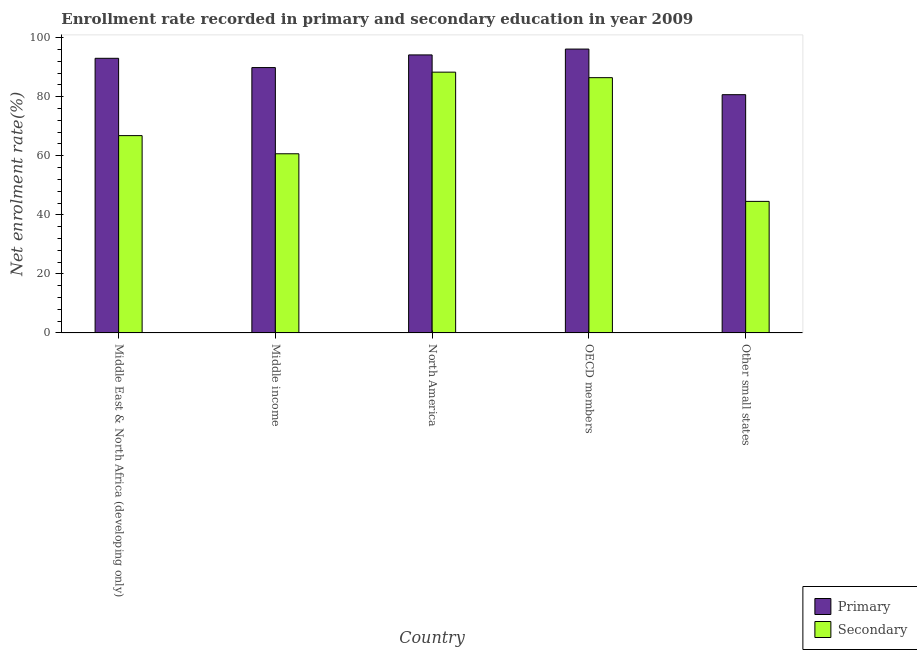How many different coloured bars are there?
Give a very brief answer. 2. How many groups of bars are there?
Your answer should be very brief. 5. Are the number of bars per tick equal to the number of legend labels?
Offer a very short reply. Yes. How many bars are there on the 3rd tick from the left?
Make the answer very short. 2. What is the label of the 5th group of bars from the left?
Your answer should be very brief. Other small states. What is the enrollment rate in secondary education in Middle income?
Ensure brevity in your answer.  60.68. Across all countries, what is the maximum enrollment rate in secondary education?
Offer a terse response. 88.32. Across all countries, what is the minimum enrollment rate in secondary education?
Your answer should be compact. 44.55. In which country was the enrollment rate in primary education minimum?
Your answer should be compact. Other small states. What is the total enrollment rate in secondary education in the graph?
Provide a short and direct response. 346.83. What is the difference between the enrollment rate in secondary education in Middle East & North Africa (developing only) and that in OECD members?
Offer a very short reply. -19.63. What is the difference between the enrollment rate in primary education in Middle East & North Africa (developing only) and the enrollment rate in secondary education in Other small states?
Ensure brevity in your answer.  48.45. What is the average enrollment rate in primary education per country?
Give a very brief answer. 90.77. What is the difference between the enrollment rate in primary education and enrollment rate in secondary education in Middle East & North Africa (developing only)?
Offer a very short reply. 26.18. In how many countries, is the enrollment rate in primary education greater than 44 %?
Ensure brevity in your answer.  5. What is the ratio of the enrollment rate in secondary education in North America to that in Other small states?
Your answer should be compact. 1.98. Is the enrollment rate in primary education in Middle income less than that in OECD members?
Ensure brevity in your answer.  Yes. Is the difference between the enrollment rate in primary education in North America and Other small states greater than the difference between the enrollment rate in secondary education in North America and Other small states?
Your answer should be compact. No. What is the difference between the highest and the second highest enrollment rate in secondary education?
Provide a short and direct response. 1.87. What is the difference between the highest and the lowest enrollment rate in primary education?
Make the answer very short. 15.45. Is the sum of the enrollment rate in primary education in OECD members and Other small states greater than the maximum enrollment rate in secondary education across all countries?
Provide a succinct answer. Yes. What does the 2nd bar from the left in North America represents?
Ensure brevity in your answer.  Secondary. What does the 1st bar from the right in OECD members represents?
Keep it short and to the point. Secondary. Are all the bars in the graph horizontal?
Your answer should be very brief. No. Are the values on the major ticks of Y-axis written in scientific E-notation?
Offer a terse response. No. Does the graph contain grids?
Make the answer very short. No. How many legend labels are there?
Offer a very short reply. 2. What is the title of the graph?
Ensure brevity in your answer.  Enrollment rate recorded in primary and secondary education in year 2009. What is the label or title of the Y-axis?
Your response must be concise. Net enrolment rate(%). What is the Net enrolment rate(%) in Primary in Middle East & North Africa (developing only)?
Your response must be concise. 93.01. What is the Net enrolment rate(%) in Secondary in Middle East & North Africa (developing only)?
Offer a terse response. 66.83. What is the Net enrolment rate(%) of Primary in Middle income?
Ensure brevity in your answer.  89.87. What is the Net enrolment rate(%) of Secondary in Middle income?
Your response must be concise. 60.68. What is the Net enrolment rate(%) of Primary in North America?
Your response must be concise. 94.16. What is the Net enrolment rate(%) in Secondary in North America?
Ensure brevity in your answer.  88.32. What is the Net enrolment rate(%) of Primary in OECD members?
Ensure brevity in your answer.  96.14. What is the Net enrolment rate(%) in Secondary in OECD members?
Provide a short and direct response. 86.45. What is the Net enrolment rate(%) of Primary in Other small states?
Provide a short and direct response. 80.69. What is the Net enrolment rate(%) in Secondary in Other small states?
Offer a very short reply. 44.55. Across all countries, what is the maximum Net enrolment rate(%) of Primary?
Your answer should be very brief. 96.14. Across all countries, what is the maximum Net enrolment rate(%) in Secondary?
Give a very brief answer. 88.32. Across all countries, what is the minimum Net enrolment rate(%) of Primary?
Give a very brief answer. 80.69. Across all countries, what is the minimum Net enrolment rate(%) of Secondary?
Provide a short and direct response. 44.55. What is the total Net enrolment rate(%) of Primary in the graph?
Your answer should be compact. 453.86. What is the total Net enrolment rate(%) of Secondary in the graph?
Offer a terse response. 346.83. What is the difference between the Net enrolment rate(%) of Primary in Middle East & North Africa (developing only) and that in Middle income?
Your answer should be very brief. 3.14. What is the difference between the Net enrolment rate(%) in Secondary in Middle East & North Africa (developing only) and that in Middle income?
Provide a succinct answer. 6.15. What is the difference between the Net enrolment rate(%) of Primary in Middle East & North Africa (developing only) and that in North America?
Provide a succinct answer. -1.15. What is the difference between the Net enrolment rate(%) in Secondary in Middle East & North Africa (developing only) and that in North America?
Offer a terse response. -21.49. What is the difference between the Net enrolment rate(%) in Primary in Middle East & North Africa (developing only) and that in OECD members?
Keep it short and to the point. -3.13. What is the difference between the Net enrolment rate(%) of Secondary in Middle East & North Africa (developing only) and that in OECD members?
Your response must be concise. -19.63. What is the difference between the Net enrolment rate(%) in Primary in Middle East & North Africa (developing only) and that in Other small states?
Your response must be concise. 12.32. What is the difference between the Net enrolment rate(%) of Secondary in Middle East & North Africa (developing only) and that in Other small states?
Keep it short and to the point. 22.27. What is the difference between the Net enrolment rate(%) in Primary in Middle income and that in North America?
Keep it short and to the point. -4.29. What is the difference between the Net enrolment rate(%) in Secondary in Middle income and that in North America?
Provide a short and direct response. -27.64. What is the difference between the Net enrolment rate(%) of Primary in Middle income and that in OECD members?
Your answer should be compact. -6.27. What is the difference between the Net enrolment rate(%) in Secondary in Middle income and that in OECD members?
Offer a terse response. -25.78. What is the difference between the Net enrolment rate(%) of Primary in Middle income and that in Other small states?
Offer a very short reply. 9.18. What is the difference between the Net enrolment rate(%) of Secondary in Middle income and that in Other small states?
Offer a very short reply. 16.12. What is the difference between the Net enrolment rate(%) of Primary in North America and that in OECD members?
Keep it short and to the point. -1.98. What is the difference between the Net enrolment rate(%) of Secondary in North America and that in OECD members?
Offer a very short reply. 1.87. What is the difference between the Net enrolment rate(%) of Primary in North America and that in Other small states?
Offer a very short reply. 13.47. What is the difference between the Net enrolment rate(%) in Secondary in North America and that in Other small states?
Make the answer very short. 43.77. What is the difference between the Net enrolment rate(%) in Primary in OECD members and that in Other small states?
Make the answer very short. 15.45. What is the difference between the Net enrolment rate(%) of Secondary in OECD members and that in Other small states?
Your answer should be very brief. 41.9. What is the difference between the Net enrolment rate(%) in Primary in Middle East & North Africa (developing only) and the Net enrolment rate(%) in Secondary in Middle income?
Your answer should be compact. 32.33. What is the difference between the Net enrolment rate(%) of Primary in Middle East & North Africa (developing only) and the Net enrolment rate(%) of Secondary in North America?
Keep it short and to the point. 4.69. What is the difference between the Net enrolment rate(%) in Primary in Middle East & North Africa (developing only) and the Net enrolment rate(%) in Secondary in OECD members?
Your answer should be very brief. 6.56. What is the difference between the Net enrolment rate(%) of Primary in Middle East & North Africa (developing only) and the Net enrolment rate(%) of Secondary in Other small states?
Your answer should be compact. 48.45. What is the difference between the Net enrolment rate(%) in Primary in Middle income and the Net enrolment rate(%) in Secondary in North America?
Your answer should be very brief. 1.55. What is the difference between the Net enrolment rate(%) in Primary in Middle income and the Net enrolment rate(%) in Secondary in OECD members?
Offer a terse response. 3.42. What is the difference between the Net enrolment rate(%) in Primary in Middle income and the Net enrolment rate(%) in Secondary in Other small states?
Your response must be concise. 45.31. What is the difference between the Net enrolment rate(%) in Primary in North America and the Net enrolment rate(%) in Secondary in OECD members?
Offer a very short reply. 7.71. What is the difference between the Net enrolment rate(%) in Primary in North America and the Net enrolment rate(%) in Secondary in Other small states?
Ensure brevity in your answer.  49.6. What is the difference between the Net enrolment rate(%) in Primary in OECD members and the Net enrolment rate(%) in Secondary in Other small states?
Provide a succinct answer. 51.58. What is the average Net enrolment rate(%) of Primary per country?
Ensure brevity in your answer.  90.77. What is the average Net enrolment rate(%) of Secondary per country?
Your response must be concise. 69.37. What is the difference between the Net enrolment rate(%) in Primary and Net enrolment rate(%) in Secondary in Middle East & North Africa (developing only)?
Offer a terse response. 26.18. What is the difference between the Net enrolment rate(%) in Primary and Net enrolment rate(%) in Secondary in Middle income?
Your answer should be compact. 29.19. What is the difference between the Net enrolment rate(%) in Primary and Net enrolment rate(%) in Secondary in North America?
Make the answer very short. 5.84. What is the difference between the Net enrolment rate(%) of Primary and Net enrolment rate(%) of Secondary in OECD members?
Provide a succinct answer. 9.68. What is the difference between the Net enrolment rate(%) of Primary and Net enrolment rate(%) of Secondary in Other small states?
Your answer should be very brief. 36.14. What is the ratio of the Net enrolment rate(%) in Primary in Middle East & North Africa (developing only) to that in Middle income?
Ensure brevity in your answer.  1.03. What is the ratio of the Net enrolment rate(%) of Secondary in Middle East & North Africa (developing only) to that in Middle income?
Your response must be concise. 1.1. What is the ratio of the Net enrolment rate(%) of Secondary in Middle East & North Africa (developing only) to that in North America?
Keep it short and to the point. 0.76. What is the ratio of the Net enrolment rate(%) of Primary in Middle East & North Africa (developing only) to that in OECD members?
Offer a very short reply. 0.97. What is the ratio of the Net enrolment rate(%) of Secondary in Middle East & North Africa (developing only) to that in OECD members?
Offer a terse response. 0.77. What is the ratio of the Net enrolment rate(%) in Primary in Middle East & North Africa (developing only) to that in Other small states?
Provide a short and direct response. 1.15. What is the ratio of the Net enrolment rate(%) of Secondary in Middle East & North Africa (developing only) to that in Other small states?
Offer a very short reply. 1.5. What is the ratio of the Net enrolment rate(%) of Primary in Middle income to that in North America?
Your response must be concise. 0.95. What is the ratio of the Net enrolment rate(%) in Secondary in Middle income to that in North America?
Make the answer very short. 0.69. What is the ratio of the Net enrolment rate(%) of Primary in Middle income to that in OECD members?
Offer a very short reply. 0.93. What is the ratio of the Net enrolment rate(%) in Secondary in Middle income to that in OECD members?
Give a very brief answer. 0.7. What is the ratio of the Net enrolment rate(%) in Primary in Middle income to that in Other small states?
Offer a terse response. 1.11. What is the ratio of the Net enrolment rate(%) of Secondary in Middle income to that in Other small states?
Provide a succinct answer. 1.36. What is the ratio of the Net enrolment rate(%) of Primary in North America to that in OECD members?
Give a very brief answer. 0.98. What is the ratio of the Net enrolment rate(%) of Secondary in North America to that in OECD members?
Your answer should be compact. 1.02. What is the ratio of the Net enrolment rate(%) in Primary in North America to that in Other small states?
Make the answer very short. 1.17. What is the ratio of the Net enrolment rate(%) of Secondary in North America to that in Other small states?
Provide a succinct answer. 1.98. What is the ratio of the Net enrolment rate(%) of Primary in OECD members to that in Other small states?
Offer a terse response. 1.19. What is the ratio of the Net enrolment rate(%) of Secondary in OECD members to that in Other small states?
Your response must be concise. 1.94. What is the difference between the highest and the second highest Net enrolment rate(%) of Primary?
Your response must be concise. 1.98. What is the difference between the highest and the second highest Net enrolment rate(%) of Secondary?
Give a very brief answer. 1.87. What is the difference between the highest and the lowest Net enrolment rate(%) in Primary?
Offer a very short reply. 15.45. What is the difference between the highest and the lowest Net enrolment rate(%) in Secondary?
Your response must be concise. 43.77. 